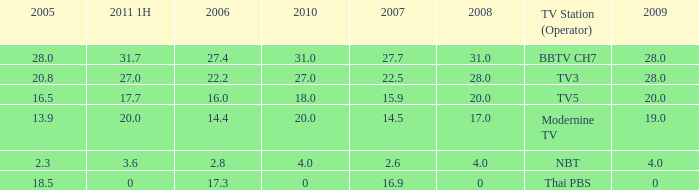What is the highest 2011 1H value for a 2005 over 28? None. 